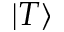<formula> <loc_0><loc_0><loc_500><loc_500>| T \rangle</formula> 